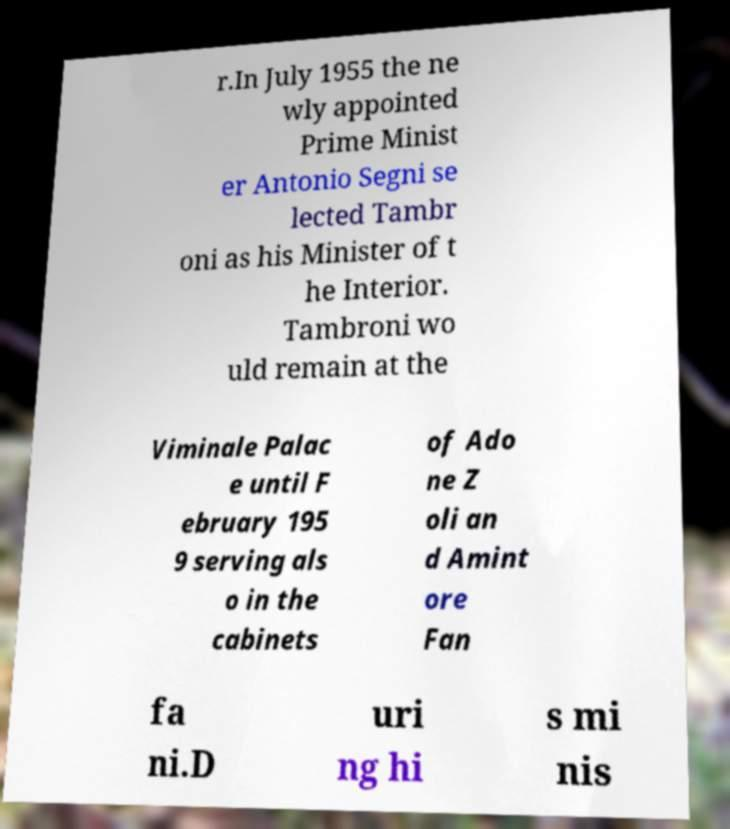Could you extract and type out the text from this image? r.In July 1955 the ne wly appointed Prime Minist er Antonio Segni se lected Tambr oni as his Minister of t he Interior. Tambroni wo uld remain at the Viminale Palac e until F ebruary 195 9 serving als o in the cabinets of Ado ne Z oli an d Amint ore Fan fa ni.D uri ng hi s mi nis 